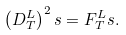<formula> <loc_0><loc_0><loc_500><loc_500>\left ( D _ { T } ^ { L } \right ) ^ { 2 } s = F _ { T } ^ { L } s .</formula> 